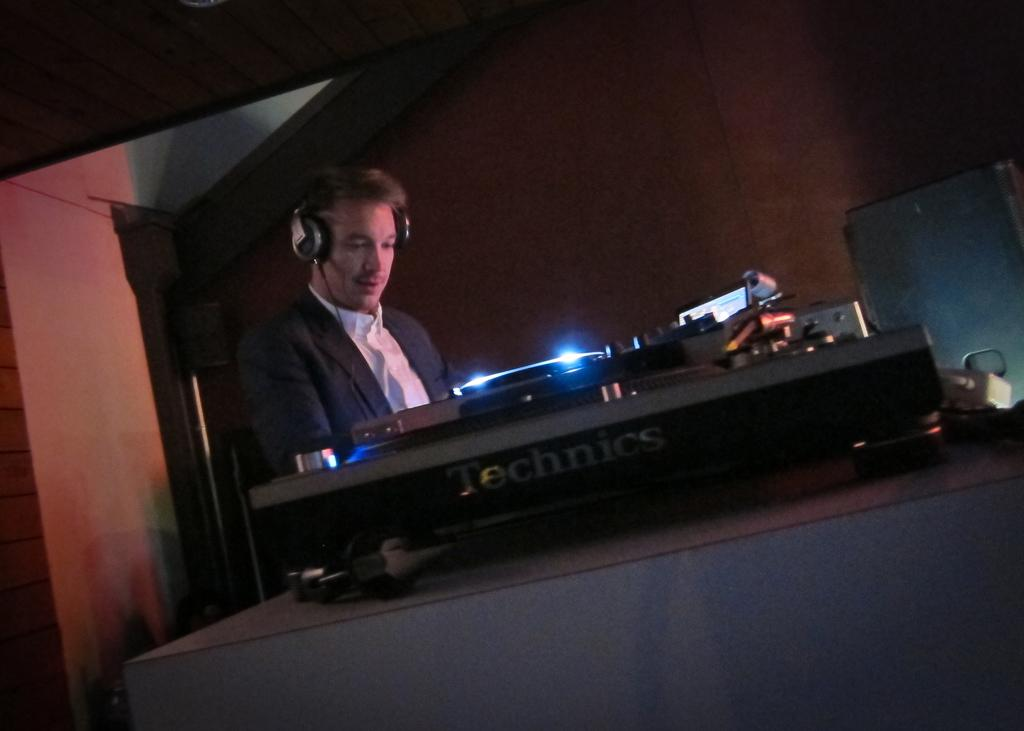Provide a one-sentence caption for the provided image. A man works on DJ equipment that says Technics on the side. 